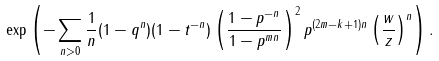Convert formula to latex. <formula><loc_0><loc_0><loc_500><loc_500>\exp \left ( - \sum _ { n > 0 } \frac { 1 } { n } ( 1 - q ^ { n } ) ( 1 - t ^ { - n } ) \left ( \frac { 1 - p ^ { - n } } { 1 - p ^ { m n } } \right ) ^ { 2 } p ^ { ( 2 m - k + 1 ) n } \left ( \frac { w } { z } \right ) ^ { n } \right ) .</formula> 